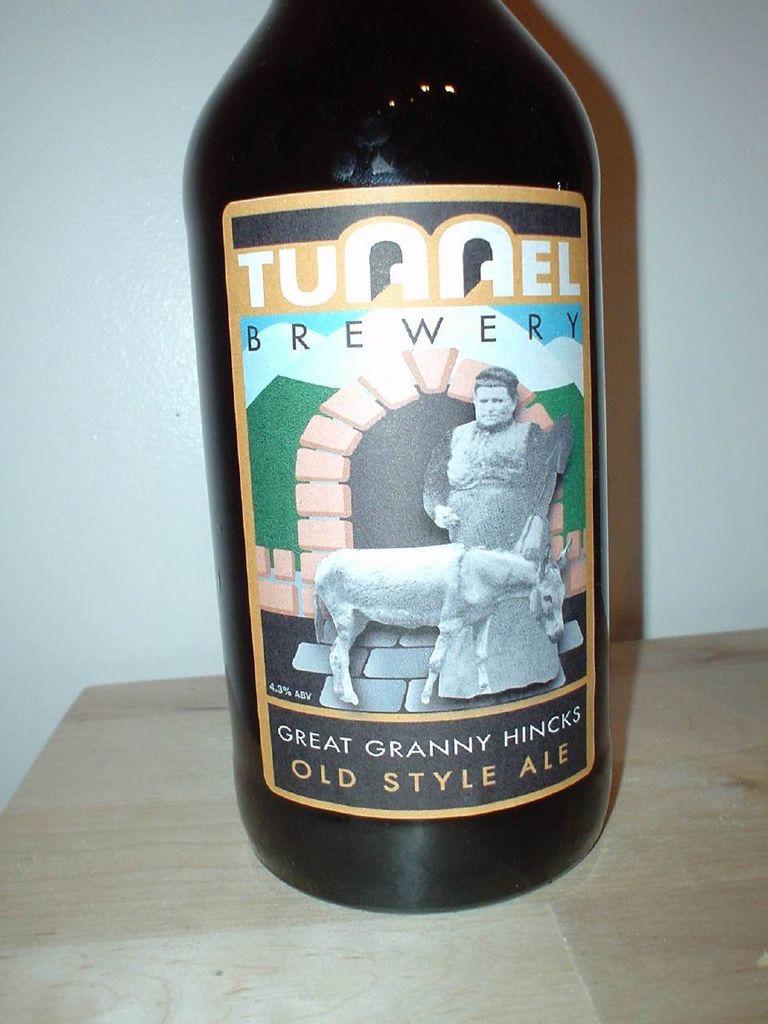What's the name of the brewery that produced the ale?
Keep it short and to the point. Tunnel. 